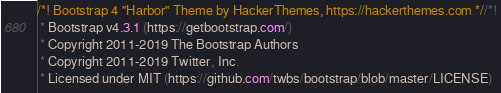<code> <loc_0><loc_0><loc_500><loc_500><_CSS_>/*! Bootstrap 4 "Harbor" Theme by HackerThemes, https://hackerthemes.com *//*!
 * Bootstrap v4.3.1 (https://getbootstrap.com/)
 * Copyright 2011-2019 The Bootstrap Authors
 * Copyright 2011-2019 Twitter, Inc.
 * Licensed under MIT (https://github.com/twbs/bootstrap/blob/master/LICENSE)</code> 